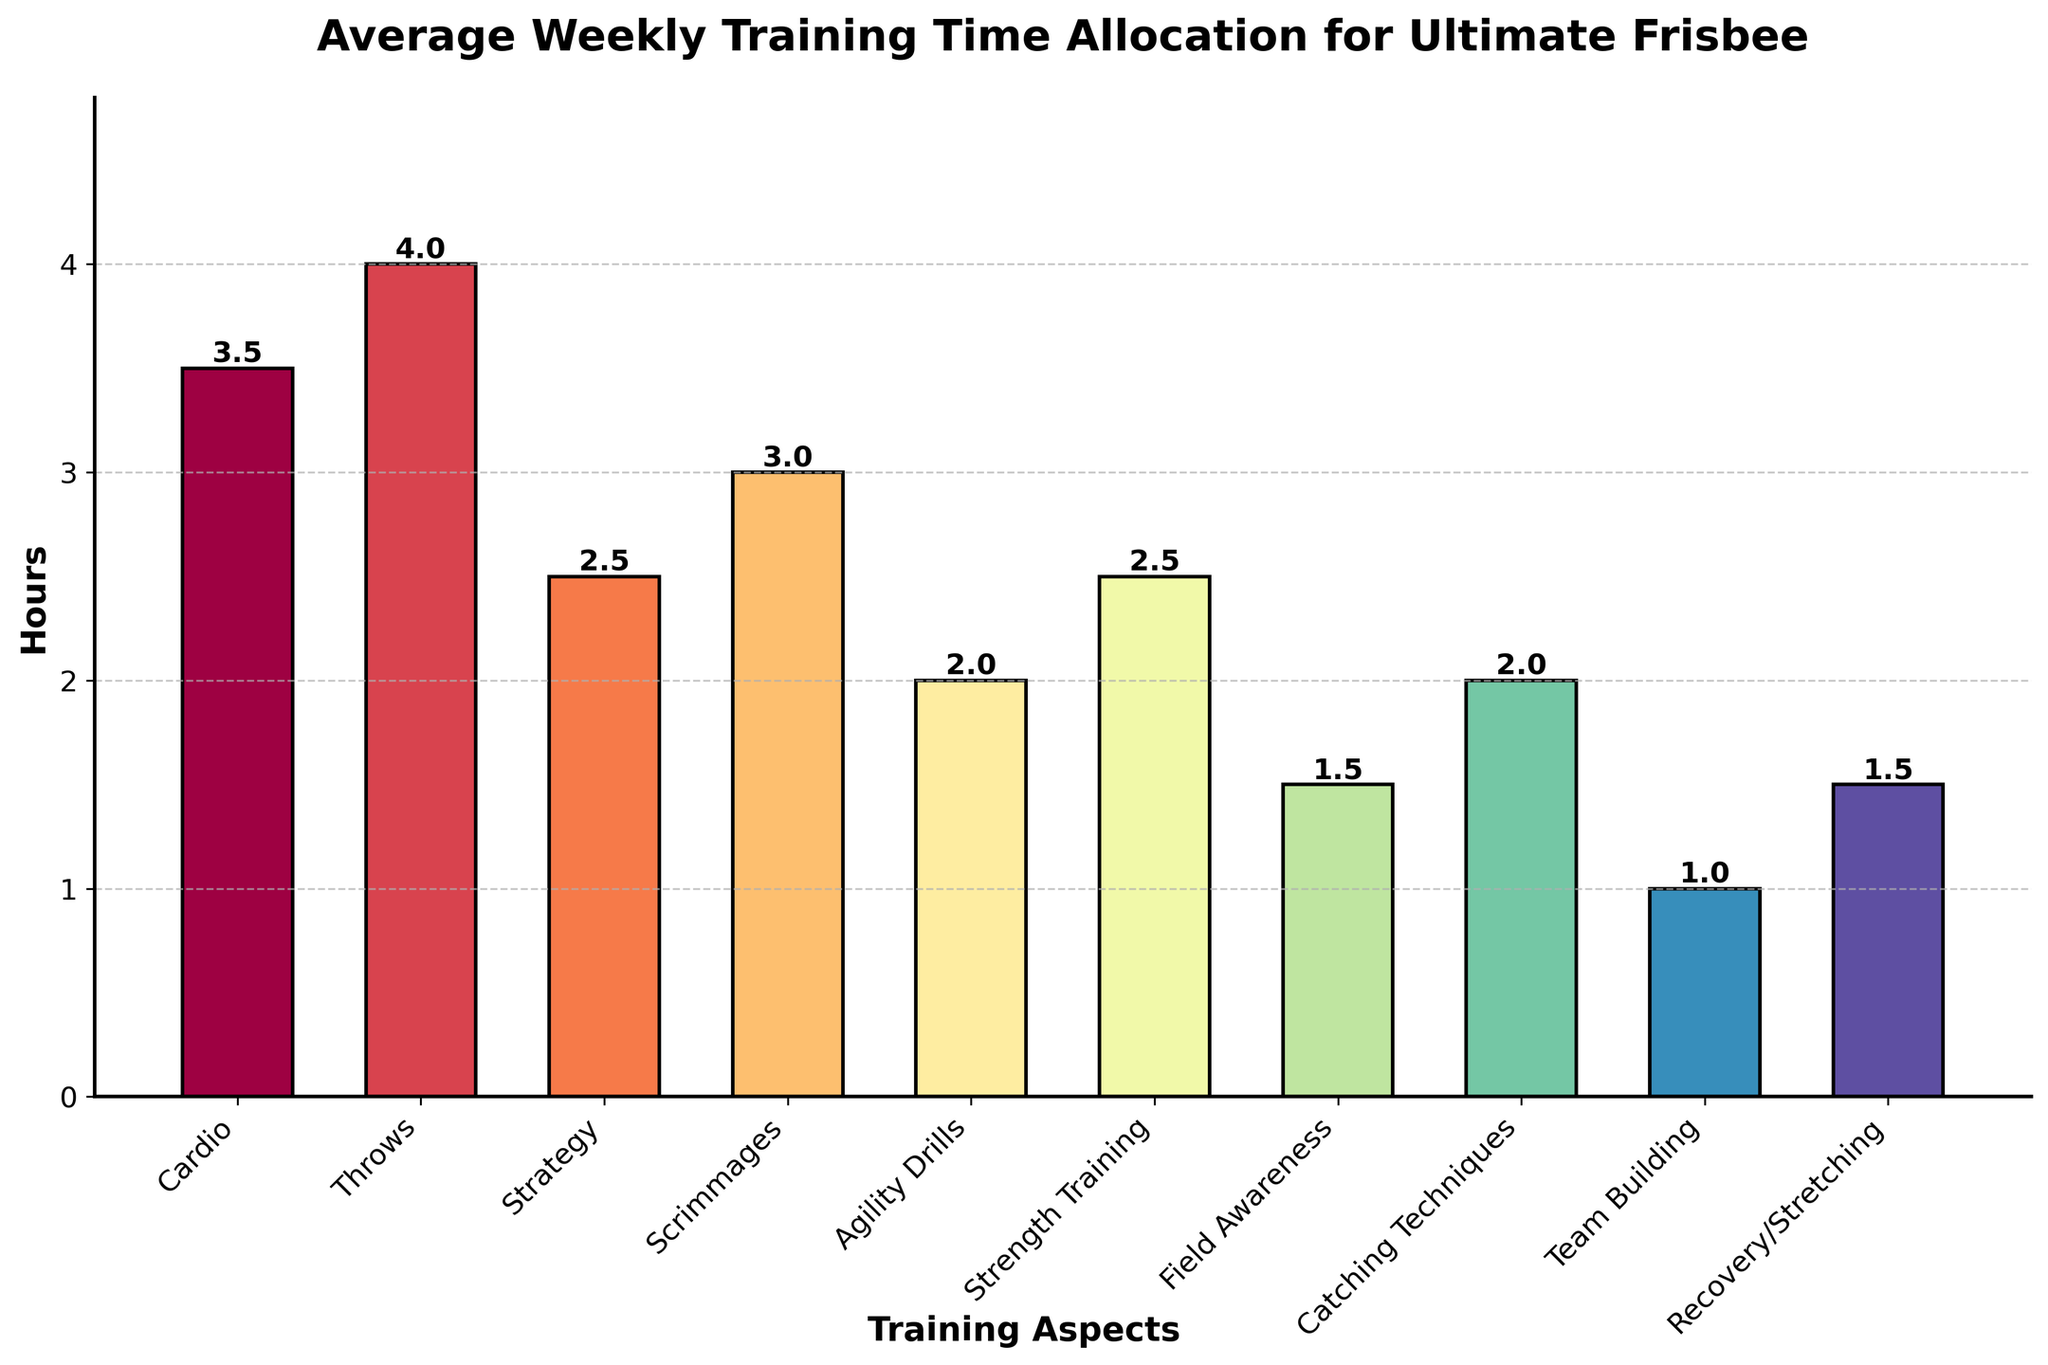What's the total time allocated to throwing techniques and strategy combined? Add the hours dedicated to throws (4.0) and strategy (2.5): 4.0 + 2.5 = 6.5 hours.
Answer: 6.5 Which training aspect has the highest average weekly training time? By looking at the heights of the bars, the throws bar is the tallest, indicating it has the highest average weekly training time.
Answer: Throws How much more time is spent on cardio compared to team building? The time spent on cardio is 3.5 hours, and on team building is 1.0 hours. The difference is 3.5 - 1.0 = 2.5 hours.
Answer: 2.5 What is the average training time per aspect? Sum the hours for all aspects and divide by the number of aspects: (3.5 + 4.0 + 2.5 + 3.0 + 2.0 + 2.5 + 1.5 + 2.0 + 1.0 + 1.5) / 10 = 2.35 hours.
Answer: 2.35 Are there more hours allocated to recovery/stretching or agility drills? Compare the respective bars. Recovery/stretching is 1.5 hours, while agility drills are 2.0 hours. Thus, there are more hours allocated to agility drills.
Answer: Agility Drills What is the difference in training time between the least and most allocated aspects? The least time is allocated to team building (1.0 hours) and the most to throws (4.0 hours). The difference is 4.0 - 1.0 = 3.0 hours.
Answer: 3.0 What is the combined training time for the aspects related to physical fitness (cardio, strength training, agility drills)? Sum the hours of cardio (3.5), strength training (2.5), and agility drills (2.0): 3.5 + 2.5 + 2.0 = 8.0 hours.
Answer: 8.0 Which aspects have exactly the same training time allocated? By comparing the heights of the bars, catching techniques and agility drills both have 2.0 hours allocated. Also, strategy and strength training both have 2.5 hours allocated.
Answer: Catching Techniques and Agility Drills; Strategy and Strength Training How many hours per week are allocated to the aspects involving direct gameplay (throws, scrimmages, catching techniques)? Sum the hours of throws (4.0), scrimmages (3.0), and catching techniques (2.0): 4.0 + 3.0 + 2.0 = 9.0 hours.
Answer: 9.0 Which bar is colored differently than most of the others and what is the allocated training time? The bars have a gradient color scheme, but none are distinctly single-colored differently. If considering relative color, point out exact training time by height comparison.
Answer: Not explicitly distinct in basic analysis 